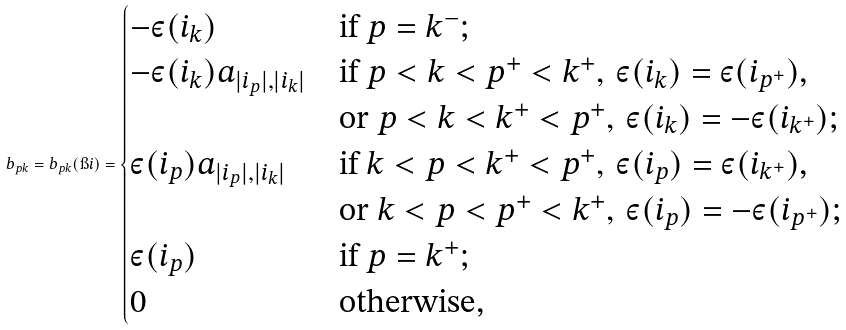Convert formula to latex. <formula><loc_0><loc_0><loc_500><loc_500>b _ { p k } = b _ { p k } ( \i i ) = \begin{cases} - \varepsilon ( i _ { k } ) & \text {if $p = k^{-}$;} \\ - \varepsilon ( i _ { k } ) a _ { | i _ { p } | , | i _ { k } | } & \text {if $p < k < p^{+} < k^{+}, \, \varepsilon (i_{k}) = \varepsilon(i_{p^{+}})$,} \\ & \text {or $p < k < k^{+} < p^{+}, \, \varepsilon (i_{k}) = -\varepsilon (i_{k^{+}})$;} \\ \varepsilon ( i _ { p } ) a _ { | i _ { p } | , | i _ { k } | } & \text {if $k < p < k^{+} < p^{+}, \, \varepsilon (i_{p}) = \varepsilon(i_{k^{+}})$,} \\ & \text {or $k < p < p^{+} < k^{+}, \, \varepsilon (i_{p}) = -\varepsilon (i_{p^{+}})$;} \\ \varepsilon ( i _ { p } ) & \text {if $p = k^{+}$;} \\ 0 & \text {otherwise,} \end{cases}</formula> 